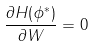<formula> <loc_0><loc_0><loc_500><loc_500>\frac { \partial H ( \phi ^ { * } ) } { \partial W } = 0</formula> 